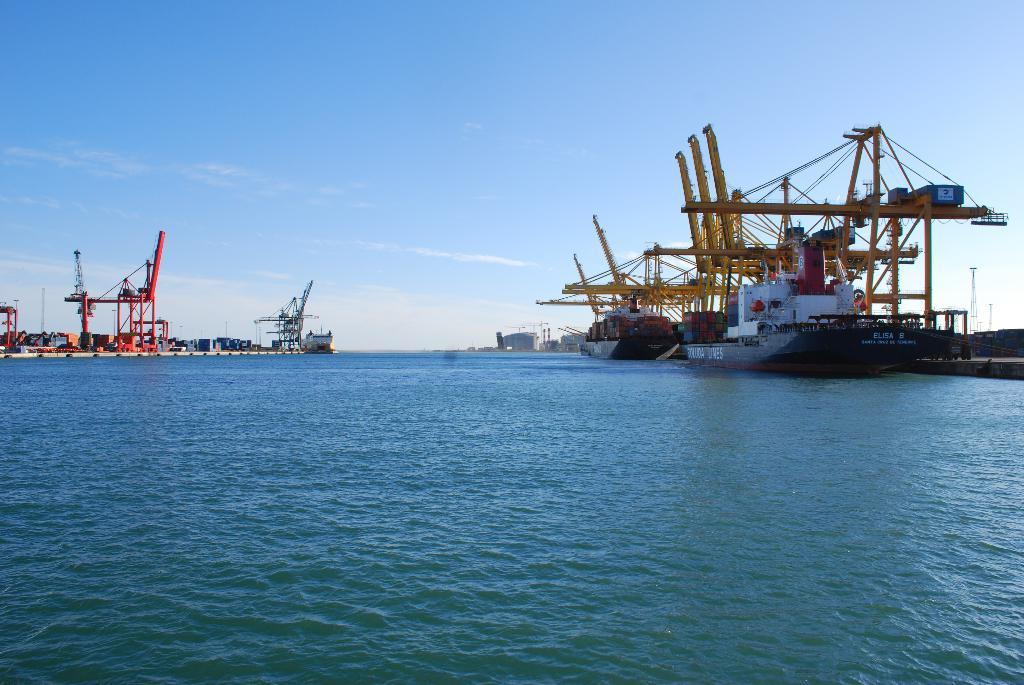What can be seen on the surface of the water in the image? There are ships on the surface of the water in the image. What is visible at the top of the image? The sky is visible at the top of the image. What structures can be seen on the right side of the image? There are towers on the right side of the image. How many boys can be seen looking at the ships in the image? There are no boys present in the image, and therefore no such activity can be observed. What type of noise can be heard coming from the ships in the image? There is no sound present in the image, so it is not possible to determine what noise might be heard. 